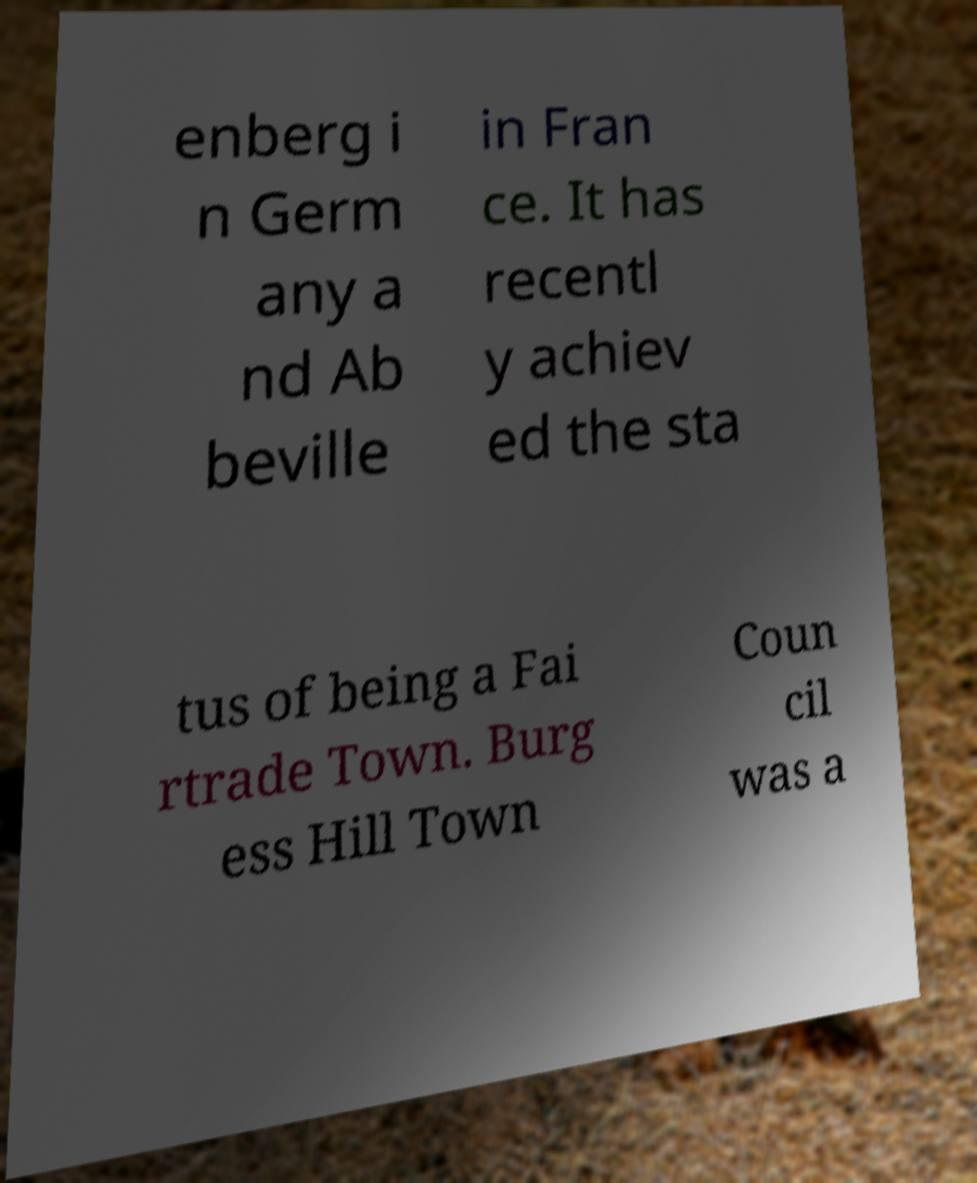Please identify and transcribe the text found in this image. enberg i n Germ any a nd Ab beville in Fran ce. It has recentl y achiev ed the sta tus of being a Fai rtrade Town. Burg ess Hill Town Coun cil was a 